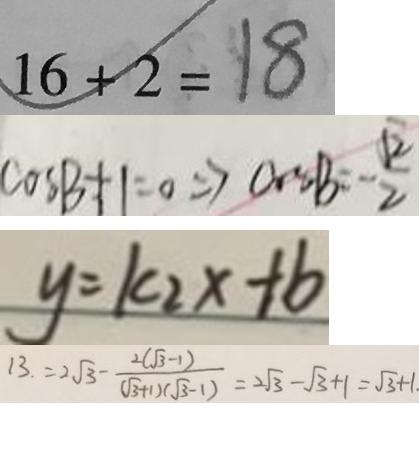Convert formula to latex. <formula><loc_0><loc_0><loc_500><loc_500>1 6 + 2 = 1 8 
 \cos B + 1 = 0 \Rightarrow \cos B = - \frac { \sqrt { 2 } } { 2 } 
 y = k _ { 2 } x + b 
 1 3 . 2 \sqrt { 3 } - \frac { 2 ( \sqrt { 3 } - 1 ) } { ( \sqrt { 3 } + 1 ) ( \sqrt { 3 } - 1 ) } = 2 \sqrt { 3 } - \sqrt { 3 } + 1 = \sqrt { 3 } + 1 .</formula> 